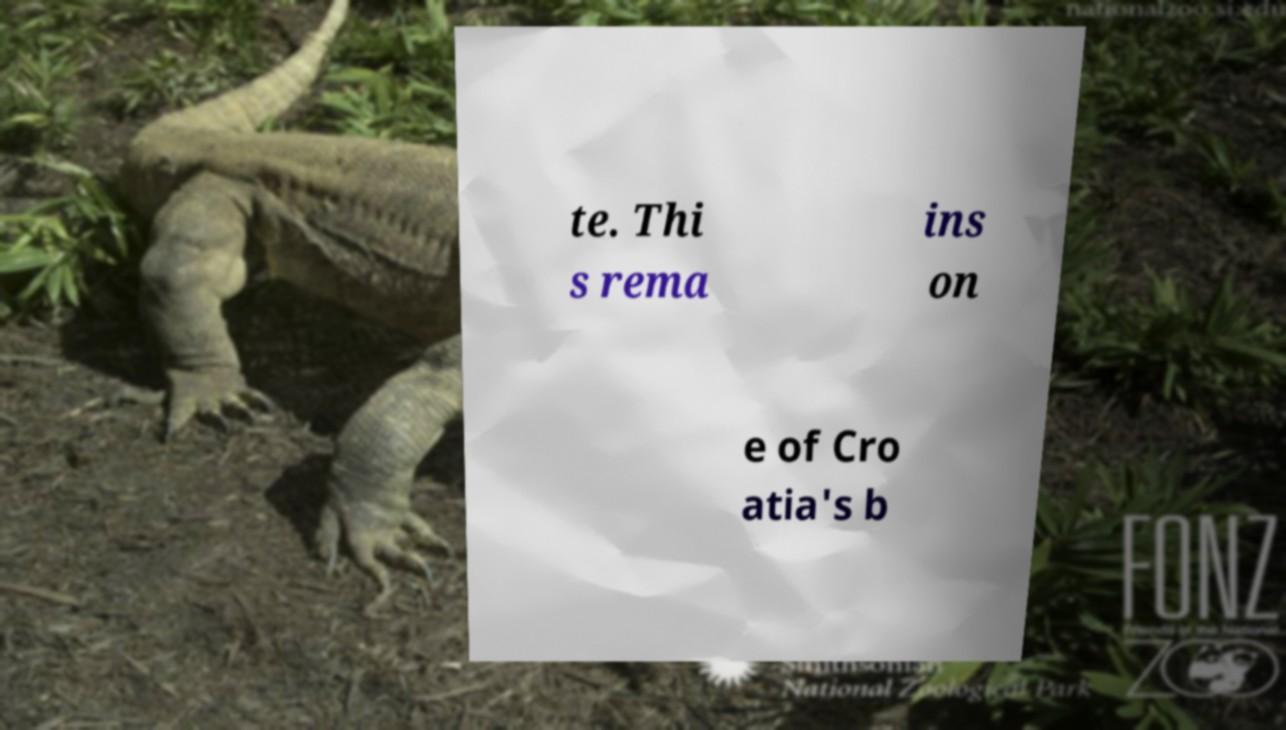For documentation purposes, I need the text within this image transcribed. Could you provide that? te. Thi s rema ins on e of Cro atia's b 